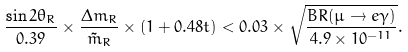<formula> <loc_0><loc_0><loc_500><loc_500>\frac { \sin 2 \theta _ { R } } { 0 . 3 9 } \times \frac { \Delta m _ { R } } { \tilde { m } _ { R } } \times ( 1 + 0 . 4 8 t ) < 0 . 0 3 \times \sqrt { \frac { B R ( \mu \rightarrow e \gamma ) } { 4 . 9 \times 1 0 ^ { - 1 1 } } } .</formula> 